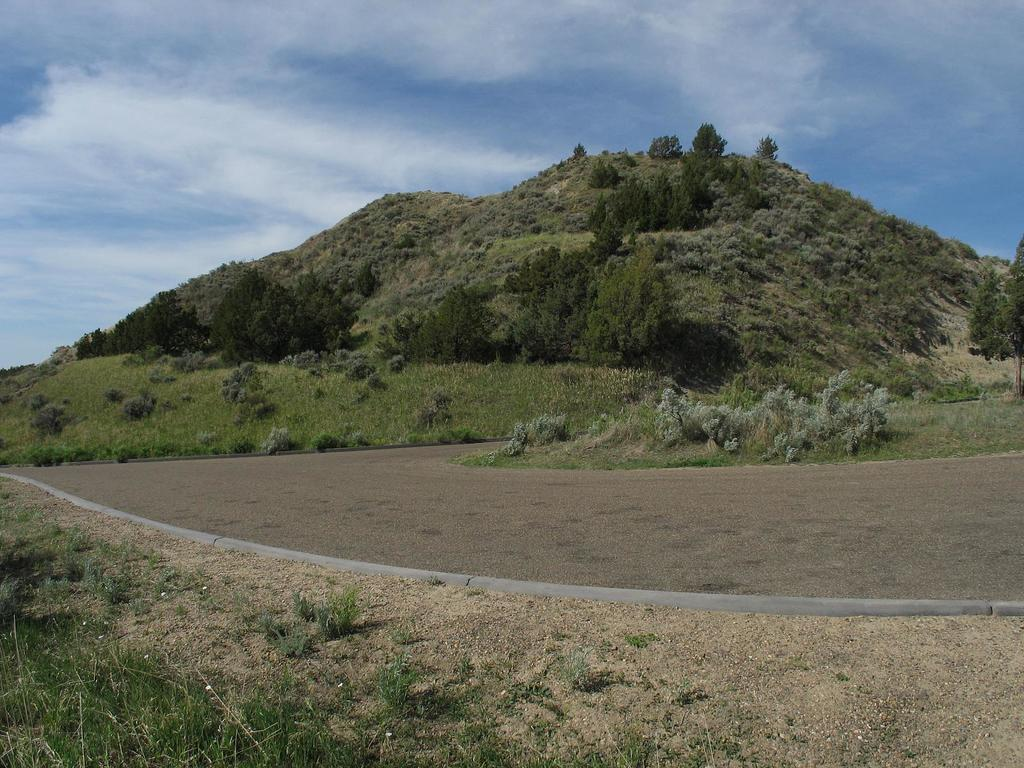What is the main feature in the center of the image? There is a hill in the center of the image. What type of vegetation can be seen in the image? There are trees in the image. What is located at the bottom of the image? There is a road and plants at the bottom of the image. What type of terrain is present at the bottom of the image? There is sand at the bottom of the image. What can be seen in the sky at the top of the image? There are clouds visible in the sky at the top of the image. Where is the chessboard located in the image? There is no chessboard present in the image. What type of pump is visible in the image? There is no pump present in the image. 